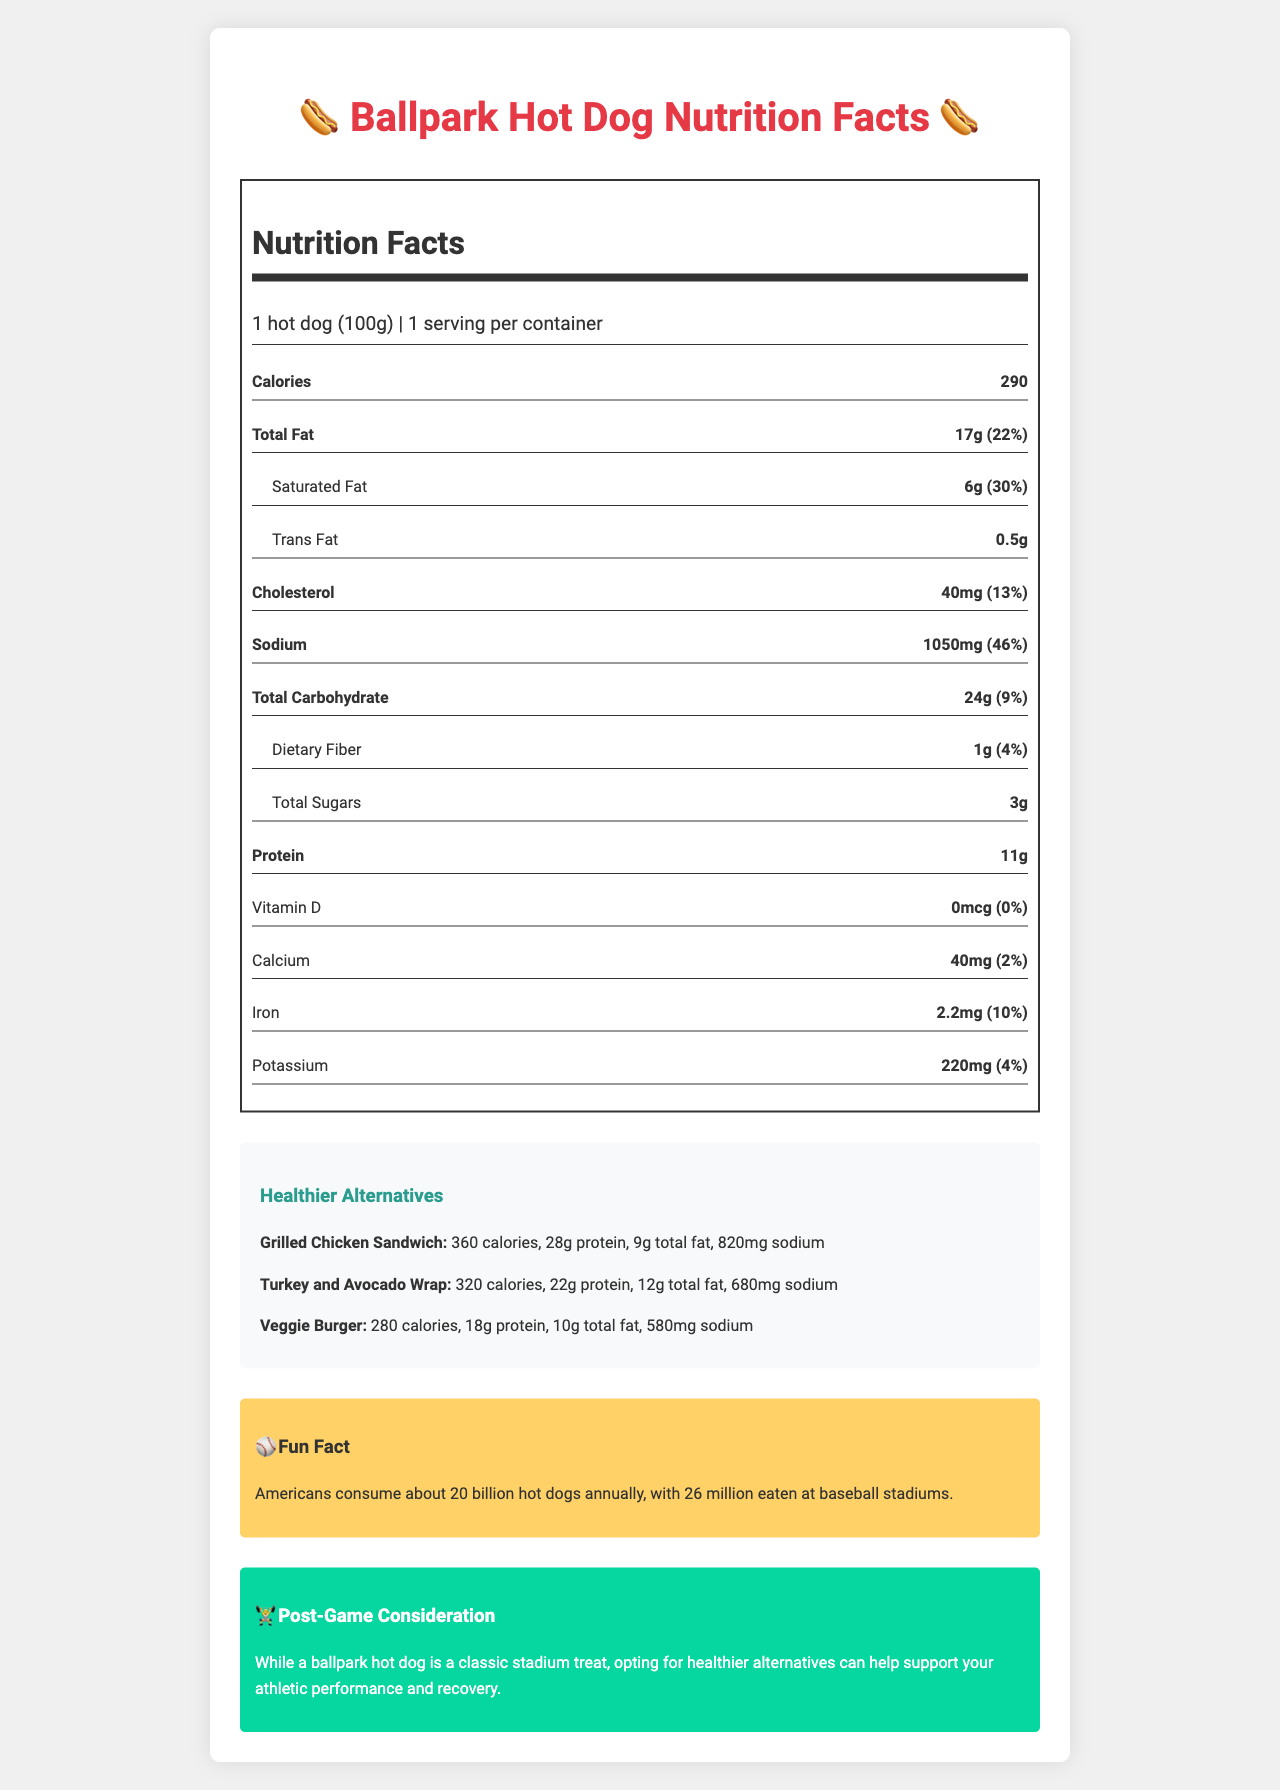what is the serving size of the Ballpark Hot Dog? The serving size is explicitly mentioned in the document as "1 hot dog (100g)".
Answer: 1 hot dog (100g) how many calories are in the Ballpark Hot Dog? The calories are listed as 290 in the document.
Answer: 290 how much protein is in the Ballpark Hot Dog? The document lists 11g of protein for the Ballpark Hot Dog.
Answer: 11g how much total fat does the Ballpark Hot Dog contain? The document specifies the total fat content as 17g.
Answer: 17g what is the sodium content of the Ballpark Hot Dog? The sodium content is listed as 1050mg in the document.
Answer: 1050mg which has the lowest number of calories? A. Ballpark Hot Dog B. Grilled Chicken Sandwich C. Turkey and Avocado Wrap D. Veggie Burger The Veggie Burger has 280 calories, which is the lowest compared to the other options.
Answer: D which alternative has the highest protein content? I. Grilled Chicken Sandwich II. Turkey and Avocado Wrap III. Veggie Burger The Grilled Chicken Sandwich has the highest protein content of 28g.
Answer: I is the Ballpark Hot Dog high in saturated fat? The Ballpark Hot Dog contains 6g of saturated fat, which is 30% of the daily value, indicating it is high in saturated fat.
Answer: Yes summarize the main idea of the document. The document's purpose is to inform readers about the nutritional content of the Ballpark Hot Dog and suggest healthier alternatives while also sharing fun trivia and advising on post-game nutrition for better athletic performance.
Answer: The document provides the nutrition facts for the Ballpark Hot Dog, compares it to healthier alternatives, and includes additional fun facts and post-game nutrition considerations. what percentage of the daily value for sodium does the Ballpark Hot Dog provide? The document states that the sodium content of 1050mg represents 46% of the daily value.
Answer: 46% how much calcium is present in the Ballpark Hot Dog? The document lists the calcium content as 40mg.
Answer: 40mg which healthier alternative has the lowest sodium content? The Veggie Burger has the lowest sodium content at 580mg.
Answer: Veggie Burger what are the common toppings for a Ballpark Hot Dog? The document lists typical hot dog toppings.
Answer: mustard, ketchup, relish, onions how much dietary fiber does the Ballpark Hot Dog contain? The dietary fiber content is stated as 1g in the document.
Answer: 1g where are Fenway Frank and Dodger Dog varieties served? The document mentions these varieties but does not specify the locations where they are served.
Answer: Cannot be determined 